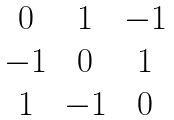Convert formula to latex. <formula><loc_0><loc_0><loc_500><loc_500>\begin{matrix} 0 & 1 & - 1 \\ - 1 & 0 & 1 \\ 1 & - 1 & 0 \end{matrix}</formula> 